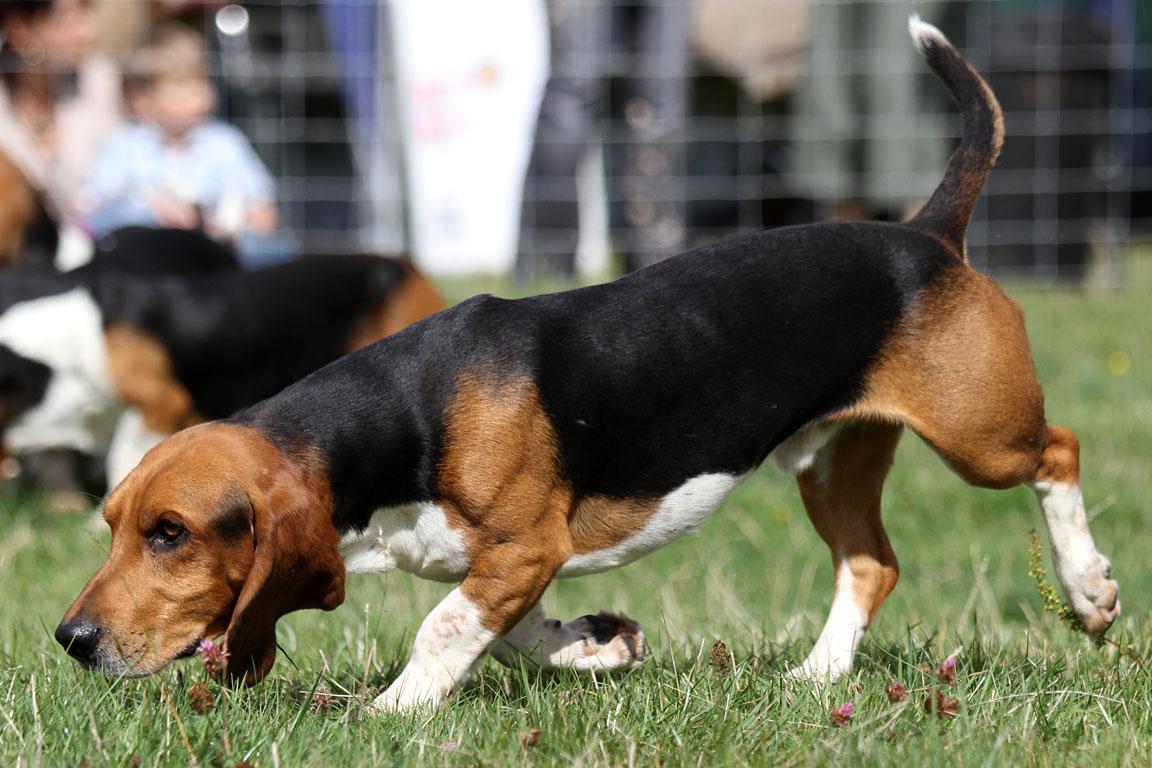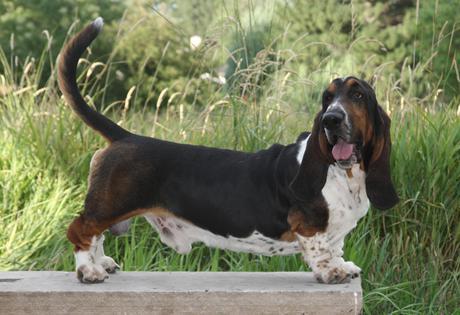The first image is the image on the left, the second image is the image on the right. Evaluate the accuracy of this statement regarding the images: "One of the images shows a basset hound with its body pointed toward the right.". Is it true? Answer yes or no. Yes. The first image is the image on the left, the second image is the image on the right. Evaluate the accuracy of this statement regarding the images: "There are 2 dogs outdoors on the grass.". Is it true? Answer yes or no. No. 